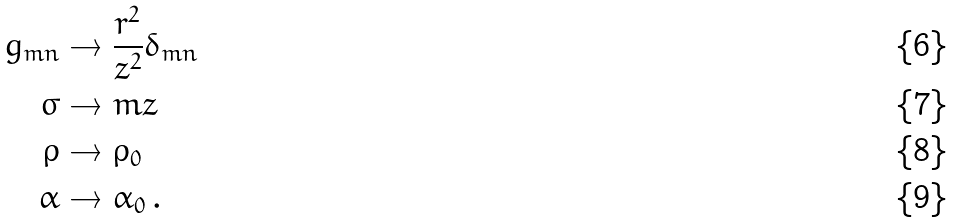<formula> <loc_0><loc_0><loc_500><loc_500>g _ { m n } & \to \frac { r ^ { 2 } } { z ^ { 2 } } \delta _ { m n } \\ \sigma & \to m z \\ \rho & \to \rho _ { 0 } \\ \alpha & \to \alpha _ { 0 } \, .</formula> 